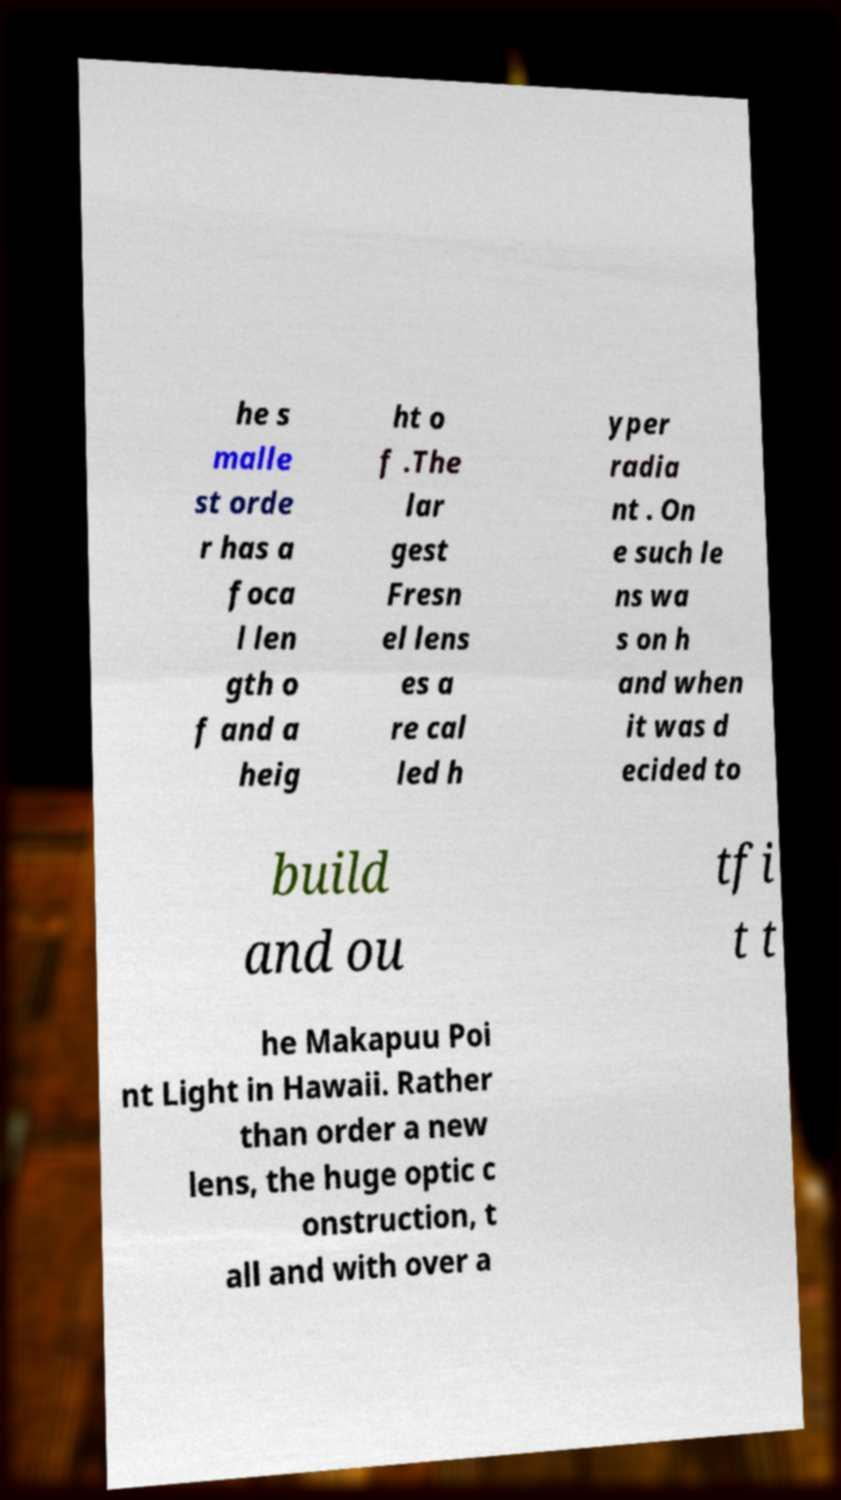Could you extract and type out the text from this image? he s malle st orde r has a foca l len gth o f and a heig ht o f .The lar gest Fresn el lens es a re cal led h yper radia nt . On e such le ns wa s on h and when it was d ecided to build and ou tfi t t he Makapuu Poi nt Light in Hawaii. Rather than order a new lens, the huge optic c onstruction, t all and with over a 